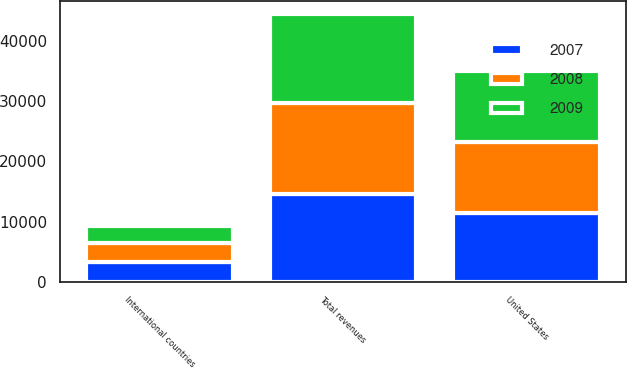Convert chart to OTSL. <chart><loc_0><loc_0><loc_500><loc_500><stacked_bar_chart><ecel><fcel>United States<fcel>International countries<fcel>Total revenues<nl><fcel>2007<fcel>11421<fcel>3221<fcel>14642<nl><fcel>2008<fcel>11772<fcel>3231<fcel>15003<nl><fcel>2009<fcel>11887<fcel>2884<fcel>14771<nl></chart> 